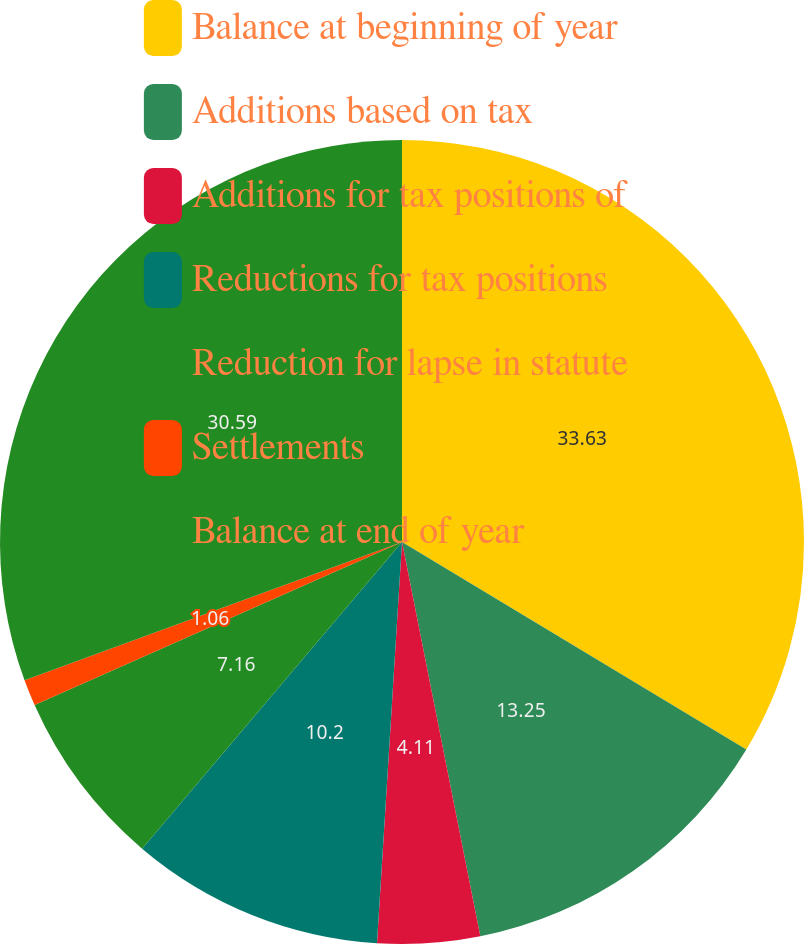<chart> <loc_0><loc_0><loc_500><loc_500><pie_chart><fcel>Balance at beginning of year<fcel>Additions based on tax<fcel>Additions for tax positions of<fcel>Reductions for tax positions<fcel>Reduction for lapse in statute<fcel>Settlements<fcel>Balance at end of year<nl><fcel>33.63%<fcel>13.25%<fcel>4.11%<fcel>10.2%<fcel>7.16%<fcel>1.06%<fcel>30.59%<nl></chart> 